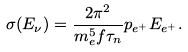Convert formula to latex. <formula><loc_0><loc_0><loc_500><loc_500>\sigma ( E _ { \nu } ) = \frac { 2 \pi ^ { 2 } } { m _ { e } ^ { 5 } f \tau _ { n } } p _ { e ^ { + } } E _ { e ^ { + } } .</formula> 